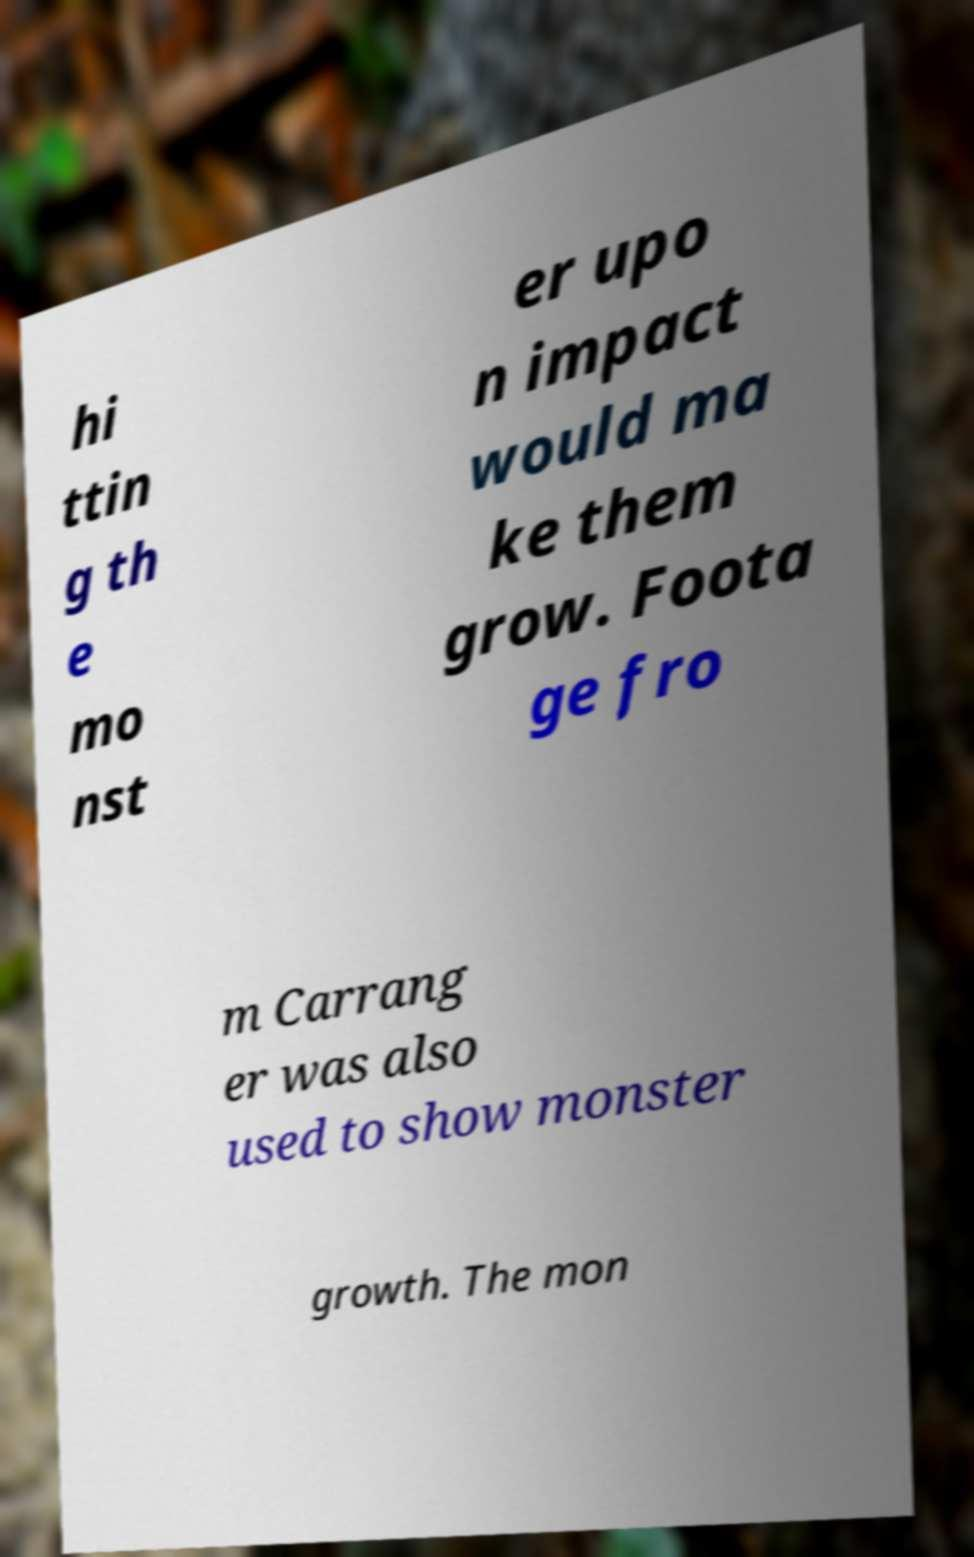Please read and relay the text visible in this image. What does it say? hi ttin g th e mo nst er upo n impact would ma ke them grow. Foota ge fro m Carrang er was also used to show monster growth. The mon 